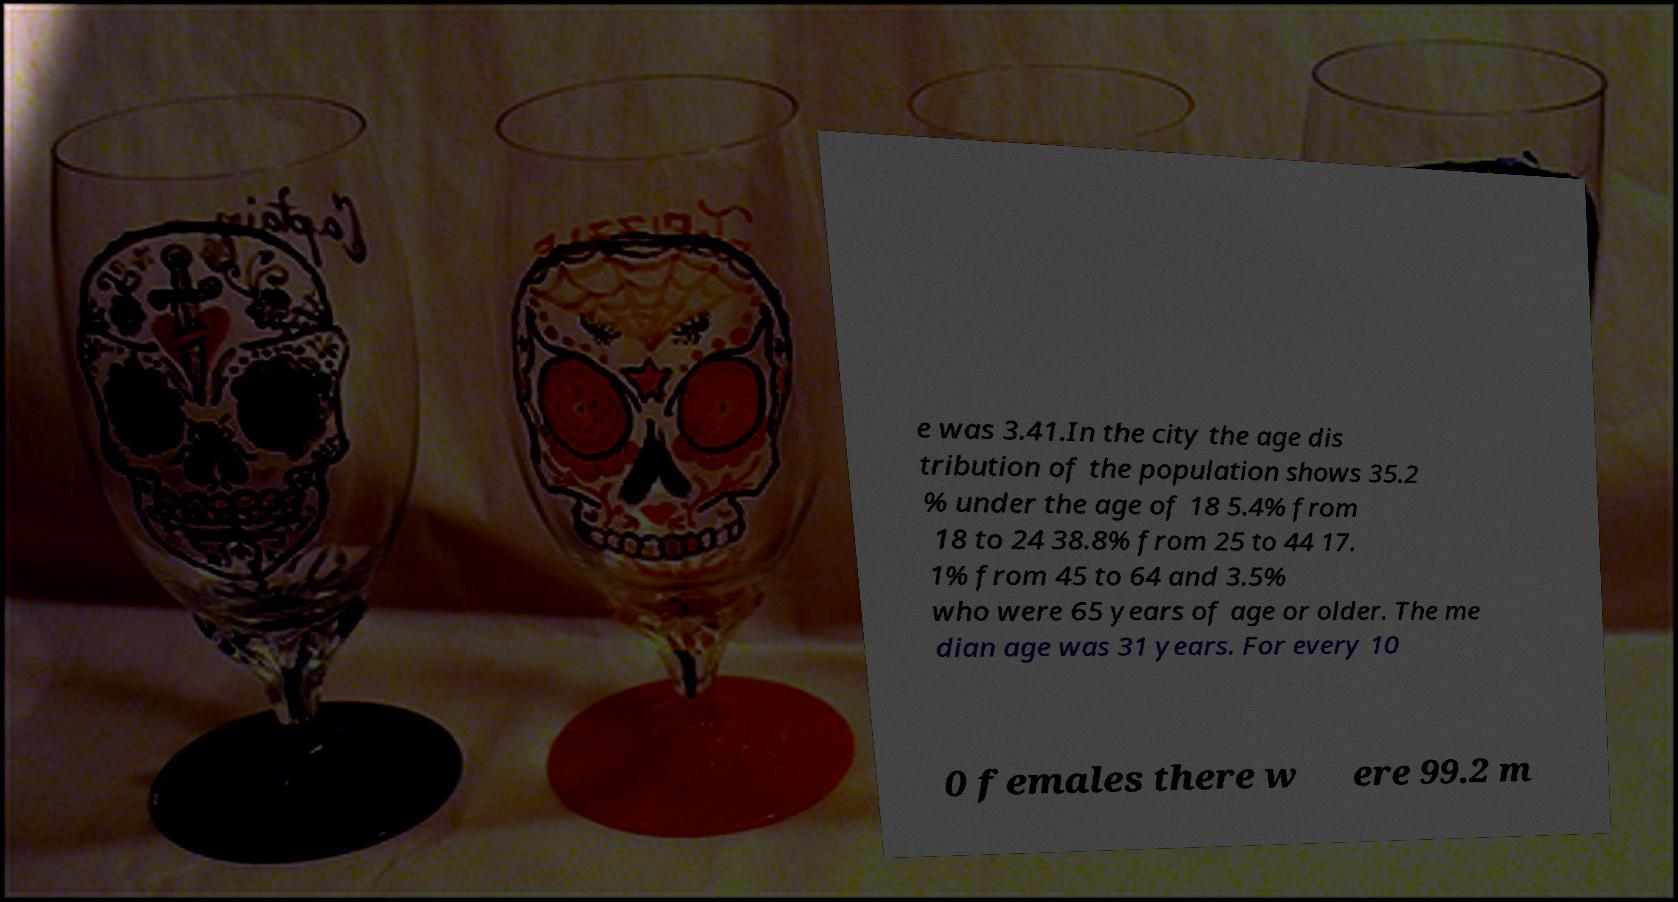Please identify and transcribe the text found in this image. e was 3.41.In the city the age dis tribution of the population shows 35.2 % under the age of 18 5.4% from 18 to 24 38.8% from 25 to 44 17. 1% from 45 to 64 and 3.5% who were 65 years of age or older. The me dian age was 31 years. For every 10 0 females there w ere 99.2 m 